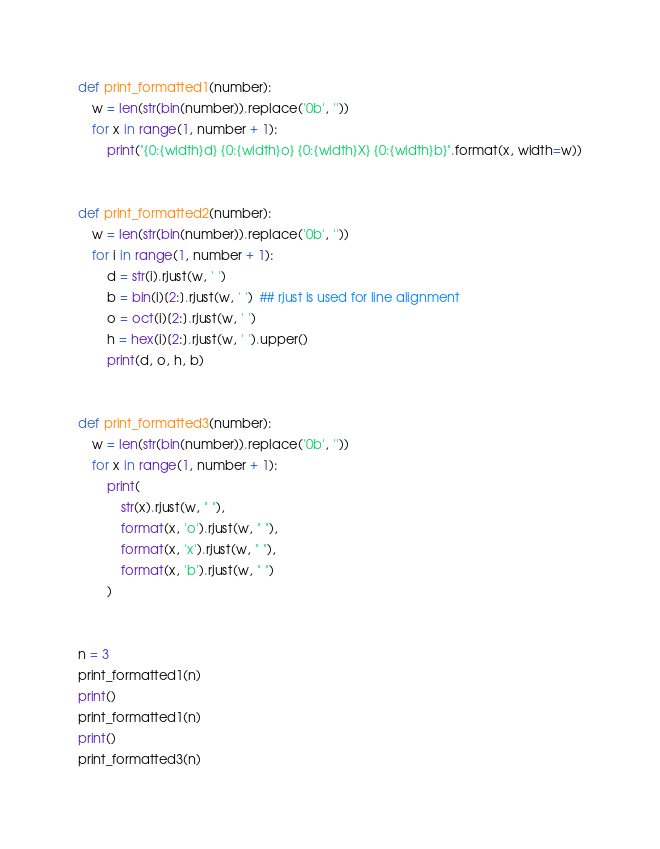Convert code to text. <code><loc_0><loc_0><loc_500><loc_500><_Python_>def print_formatted1(number):
    w = len(str(bin(number)).replace('0b', ''))
    for x in range(1, number + 1):
        print("{0:{width}d} {0:{width}o} {0:{width}X} {0:{width}b}".format(x, width=w))


def print_formatted2(number):
    w = len(str(bin(number)).replace('0b', ''))
    for i in range(1, number + 1):
        d = str(i).rjust(w, ' ')
        b = bin(i)[2:].rjust(w, ' ')  ## rjust is used for line alignment
        o = oct(i)[2:].rjust(w, ' ')
        h = hex(i)[2:].rjust(w, ' ').upper()
        print(d, o, h, b)


def print_formatted3(number):
    w = len(str(bin(number)).replace('0b', ''))
    for x in range(1, number + 1):
        print(
            str(x).rjust(w, " "),
            format(x, 'o').rjust(w, " "),
            format(x, 'x').rjust(w, " "),
            format(x, 'b').rjust(w, " ")
        )


n = 3
print_formatted1(n)
print()
print_formatted1(n)
print()
print_formatted3(n)
</code> 